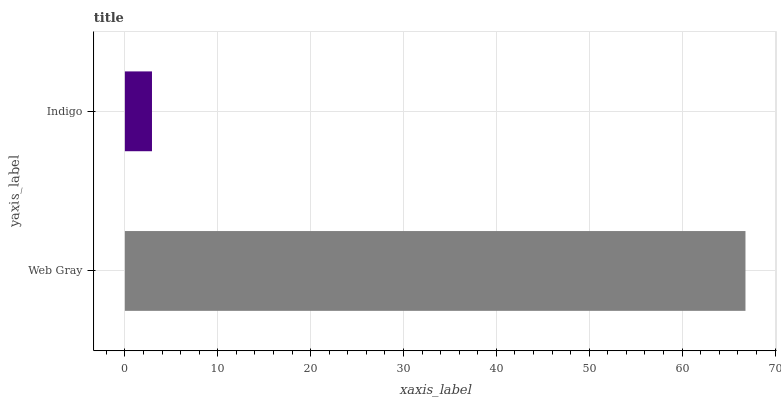Is Indigo the minimum?
Answer yes or no. Yes. Is Web Gray the maximum?
Answer yes or no. Yes. Is Indigo the maximum?
Answer yes or no. No. Is Web Gray greater than Indigo?
Answer yes or no. Yes. Is Indigo less than Web Gray?
Answer yes or no. Yes. Is Indigo greater than Web Gray?
Answer yes or no. No. Is Web Gray less than Indigo?
Answer yes or no. No. Is Web Gray the high median?
Answer yes or no. Yes. Is Indigo the low median?
Answer yes or no. Yes. Is Indigo the high median?
Answer yes or no. No. Is Web Gray the low median?
Answer yes or no. No. 